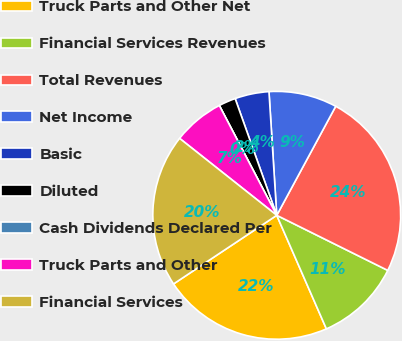Convert chart to OTSL. <chart><loc_0><loc_0><loc_500><loc_500><pie_chart><fcel>Truck Parts and Other Net<fcel>Financial Services Revenues<fcel>Total Revenues<fcel>Net Income<fcel>Basic<fcel>Diluted<fcel>Cash Dividends Declared Per<fcel>Truck Parts and Other<fcel>Financial Services<nl><fcel>22.22%<fcel>11.11%<fcel>24.44%<fcel>8.89%<fcel>4.45%<fcel>2.22%<fcel>0.0%<fcel>6.67%<fcel>20.0%<nl></chart> 